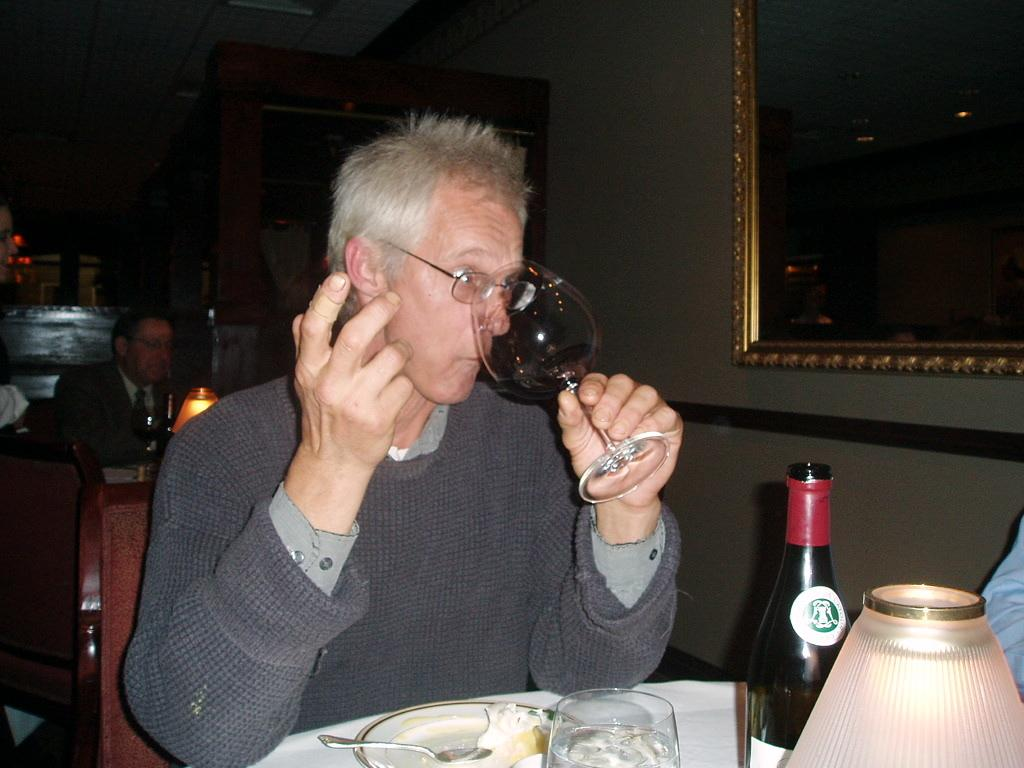Who is present in the image? There is a person in the image. What is the person wearing? The person is wearing a black jacket. What is the person doing in the image? The person is drinking. What is on the table in front of the person? The table has a plate, a spoon, a glass, a lamp, and a bottle on it. Where are the person's friends at the zoo in the image? There is no mention of friends or a zoo in the image; it only features a person drinking and a table with various items on it. 